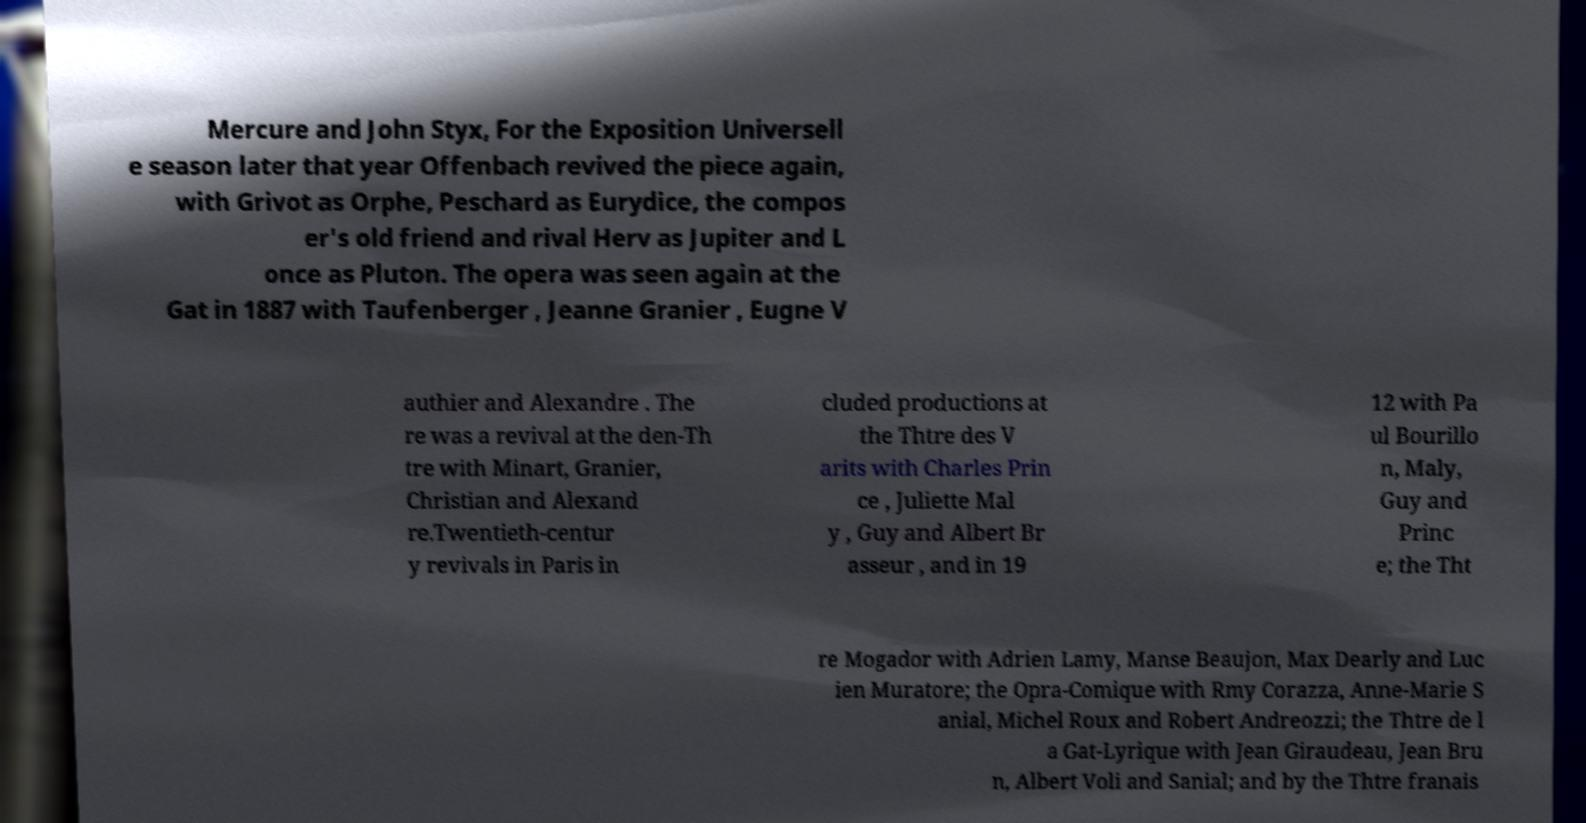Please read and relay the text visible in this image. What does it say? Mercure and John Styx, For the Exposition Universell e season later that year Offenbach revived the piece again, with Grivot as Orphe, Peschard as Eurydice, the compos er's old friend and rival Herv as Jupiter and L once as Pluton. The opera was seen again at the Gat in 1887 with Taufenberger , Jeanne Granier , Eugne V authier and Alexandre . The re was a revival at the den-Th tre with Minart, Granier, Christian and Alexand re.Twentieth-centur y revivals in Paris in cluded productions at the Thtre des V arits with Charles Prin ce , Juliette Mal y , Guy and Albert Br asseur , and in 19 12 with Pa ul Bourillo n, Maly, Guy and Princ e; the Tht re Mogador with Adrien Lamy, Manse Beaujon, Max Dearly and Luc ien Muratore; the Opra-Comique with Rmy Corazza, Anne-Marie S anial, Michel Roux and Robert Andreozzi; the Thtre de l a Gat-Lyrique with Jean Giraudeau, Jean Bru n, Albert Voli and Sanial; and by the Thtre franais 